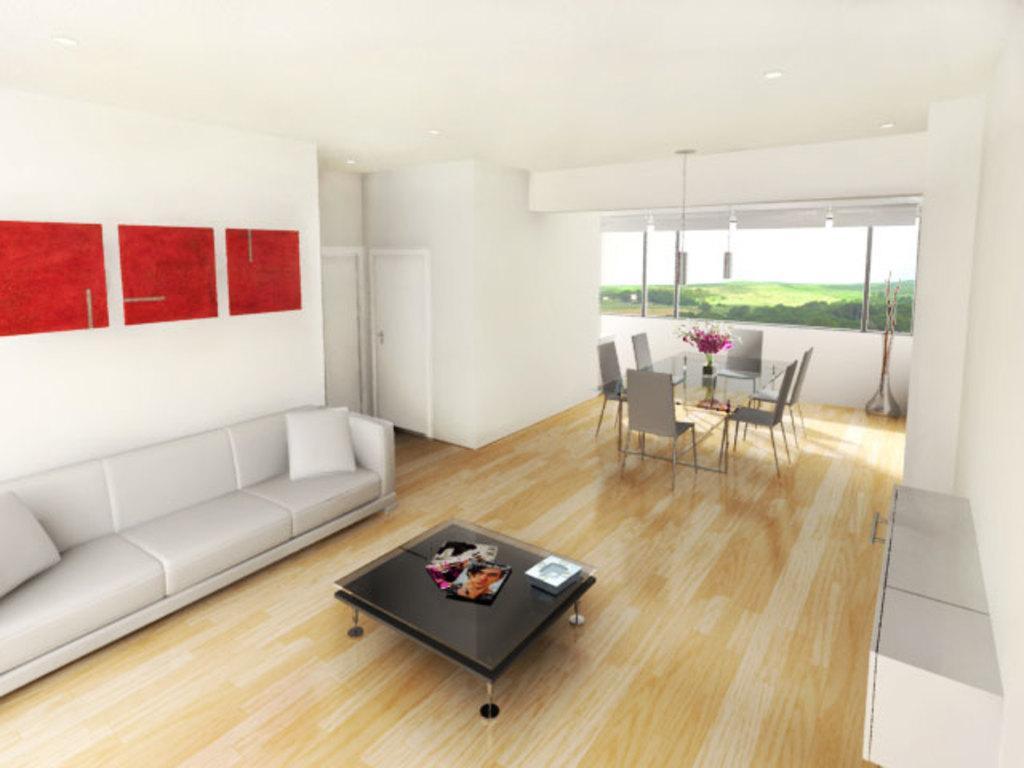Describe this image in one or two sentences. In this image is a inside picture of a room. In the center of the image there is a table. There is a wooden flooring at the bottom of the image. There is a sofa. There is a dining table. In the background of the image there is a glass window. There are doors. 